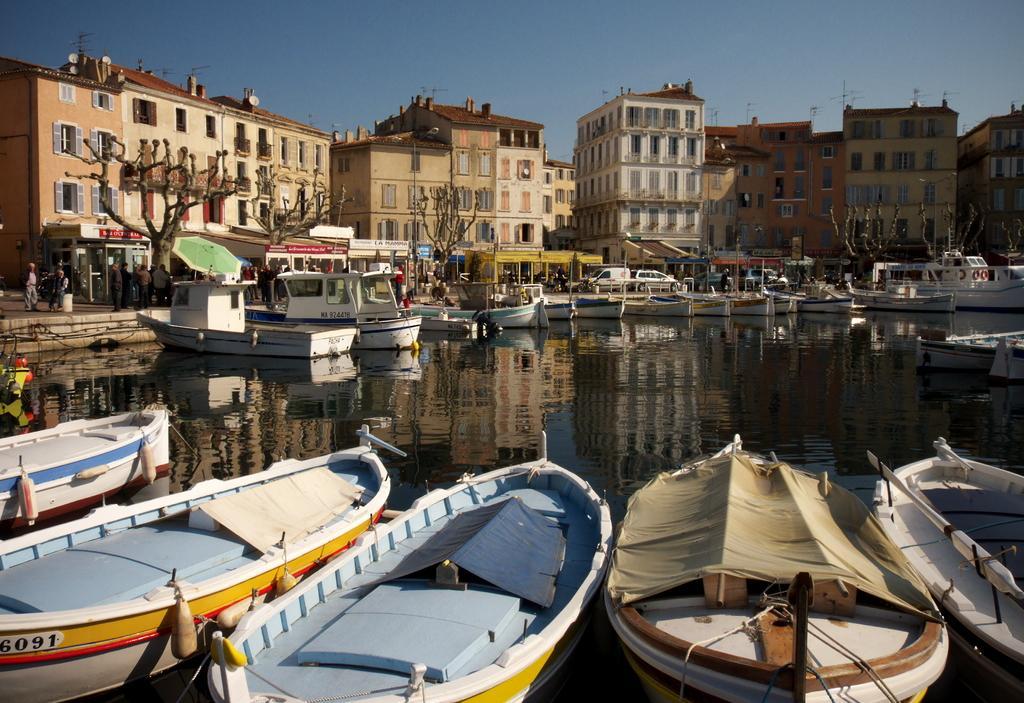How would you summarize this image in a sentence or two? In this picture we can see boats on water, buildings with windows, trees, banners, umbrella, vehicles and a group of people on a path and some objects and in the background we can see the sky. 